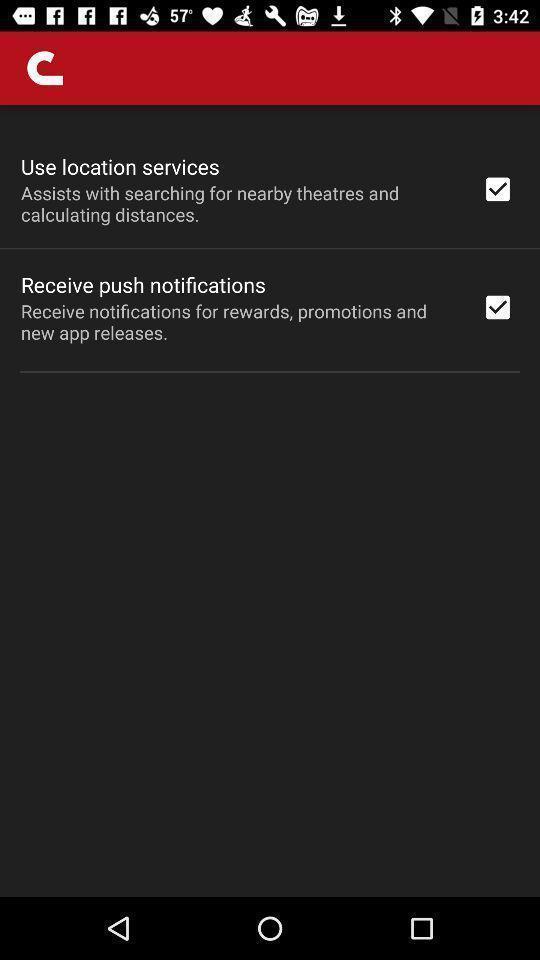What is the overall content of this screenshot? Settings page displaying in application. 